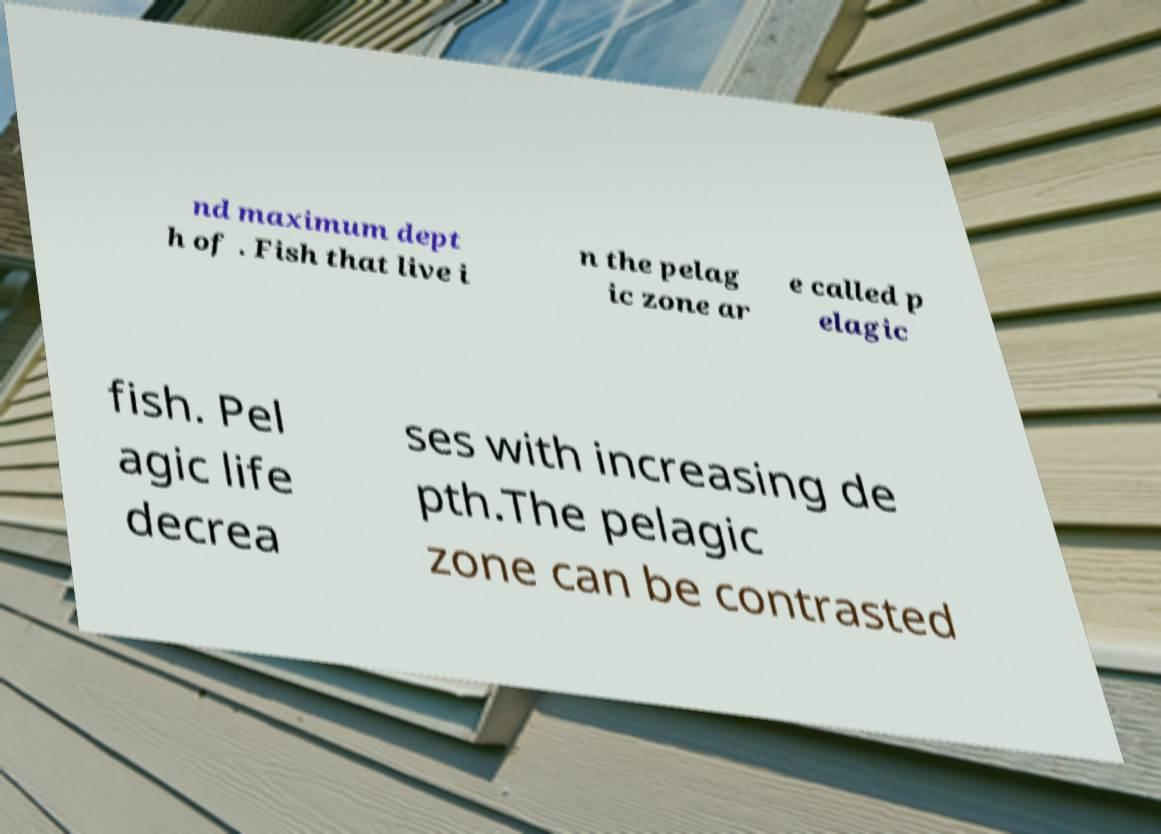I need the written content from this picture converted into text. Can you do that? nd maximum dept h of . Fish that live i n the pelag ic zone ar e called p elagic fish. Pel agic life decrea ses with increasing de pth.The pelagic zone can be contrasted 